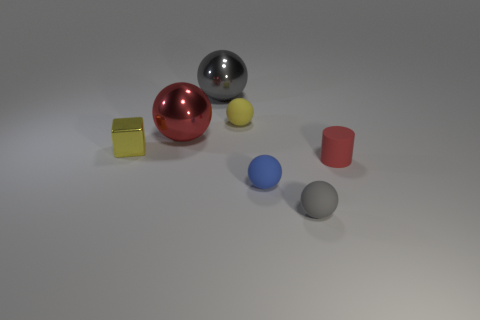Subtract all big gray metal spheres. How many spheres are left? 4 Subtract 1 balls. How many balls are left? 4 Subtract all blue balls. How many balls are left? 4 Add 1 small gray things. How many objects exist? 8 Subtract all cyan balls. Subtract all purple cylinders. How many balls are left? 5 Subtract all cylinders. How many objects are left? 6 Subtract all green metal spheres. Subtract all small objects. How many objects are left? 2 Add 3 small rubber balls. How many small rubber balls are left? 6 Add 6 small red things. How many small red things exist? 7 Subtract 0 green balls. How many objects are left? 7 